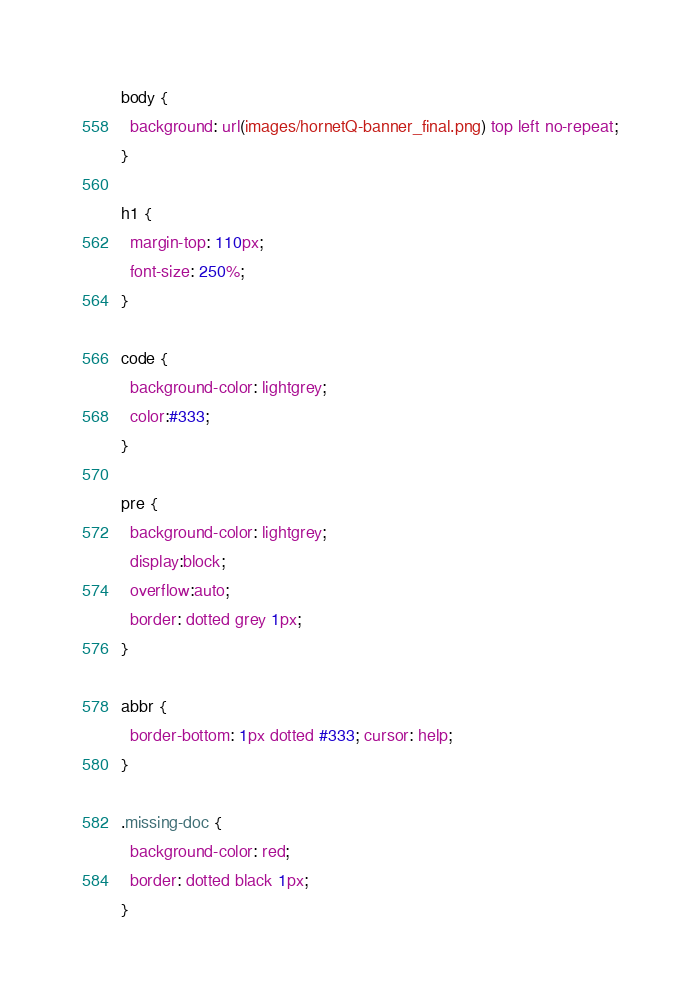Convert code to text. <code><loc_0><loc_0><loc_500><loc_500><_CSS_>body {
  background: url(images/hornetQ-banner_final.png) top left no-repeat;
}

h1 {
  margin-top: 110px;
  font-size: 250%;
}

code {
  background-color: lightgrey;
  color:#333;
}

pre {
  background-color: lightgrey;
  display:block;     
  overflow:auto; 
  border: dotted grey 1px;
}

abbr {
  border-bottom: 1px dotted #333; cursor: help;
}

.missing-doc {
  background-color: red;
  border: dotted black 1px;
}
</code> 